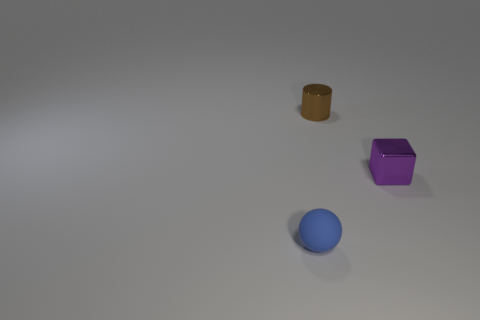Add 2 purple blocks. How many objects exist? 5 Subtract all cylinders. How many objects are left? 2 Subtract 0 brown blocks. How many objects are left? 3 Subtract all small purple things. Subtract all balls. How many objects are left? 1 Add 1 blue things. How many blue things are left? 2 Add 2 blue spheres. How many blue spheres exist? 3 